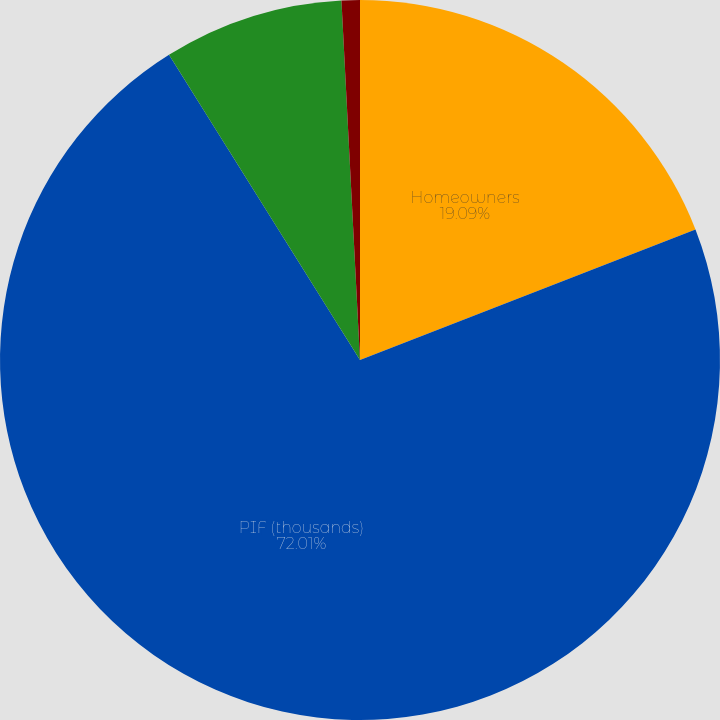<chart> <loc_0><loc_0><loc_500><loc_500><pie_chart><fcel>Homeowners<fcel>PIF (thousands)<fcel>Average premium-gross written<fcel>Renewal ratio ()<nl><fcel>19.09%<fcel>72.0%<fcel>8.08%<fcel>0.82%<nl></chart> 